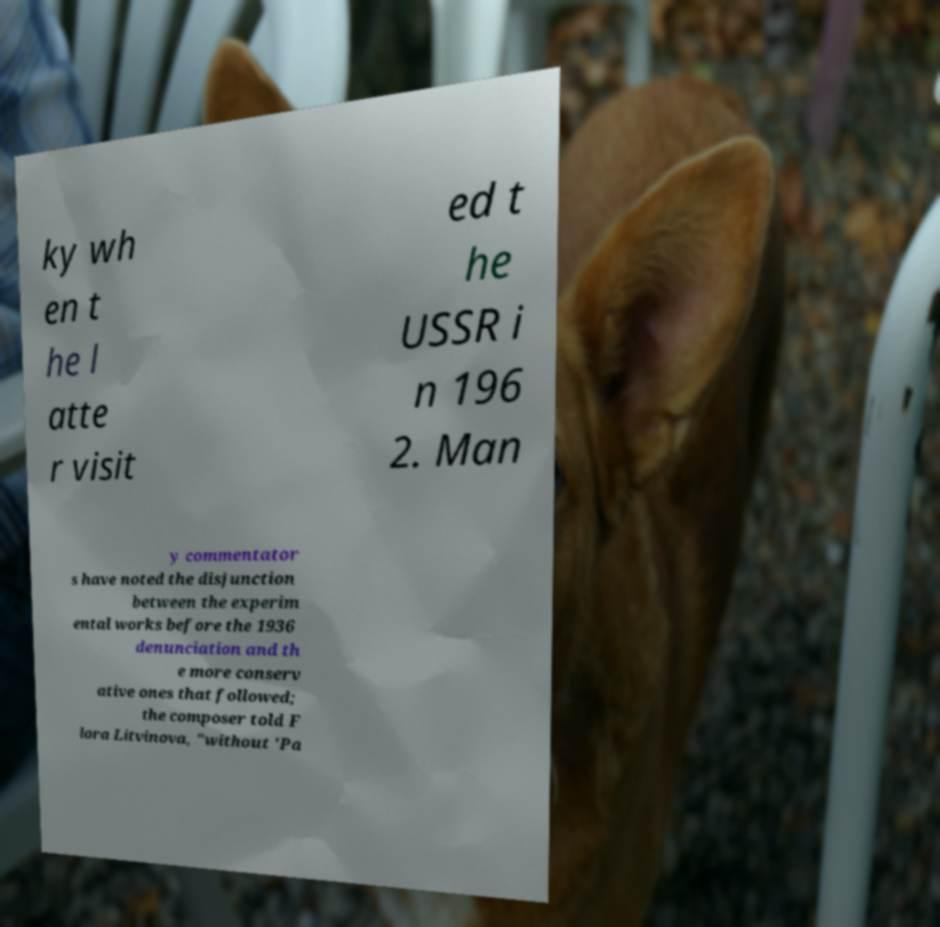What messages or text are displayed in this image? I need them in a readable, typed format. ky wh en t he l atte r visit ed t he USSR i n 196 2. Man y commentator s have noted the disjunction between the experim ental works before the 1936 denunciation and th e more conserv ative ones that followed; the composer told F lora Litvinova, "without 'Pa 